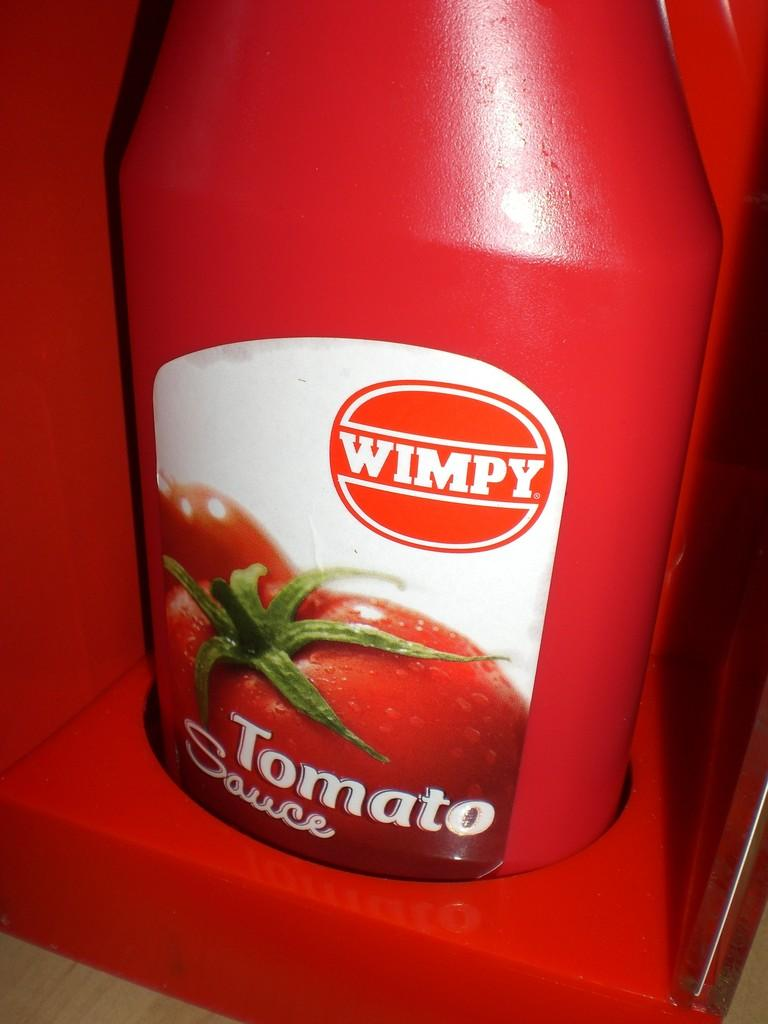What is the color of the bottle in the image? The bottle in the image is red. Is there any additional detail on the bottle? Yes, there is a sticker on the bottle. What information can be found on the sticker? The sticker contains three words. What other items are present in the image? There are tomatoes in the image. What might be the red color thing mentioned in the facts? The red color thing mentioned is likely the base or surface on which the bottle is placed. What is the rate of societal change in the image? There is no information about societal change or rates in the image; it only features a red bottle with a sticker and tomatoes. 